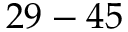<formula> <loc_0><loc_0><loc_500><loc_500>2 9 - 4 5</formula> 